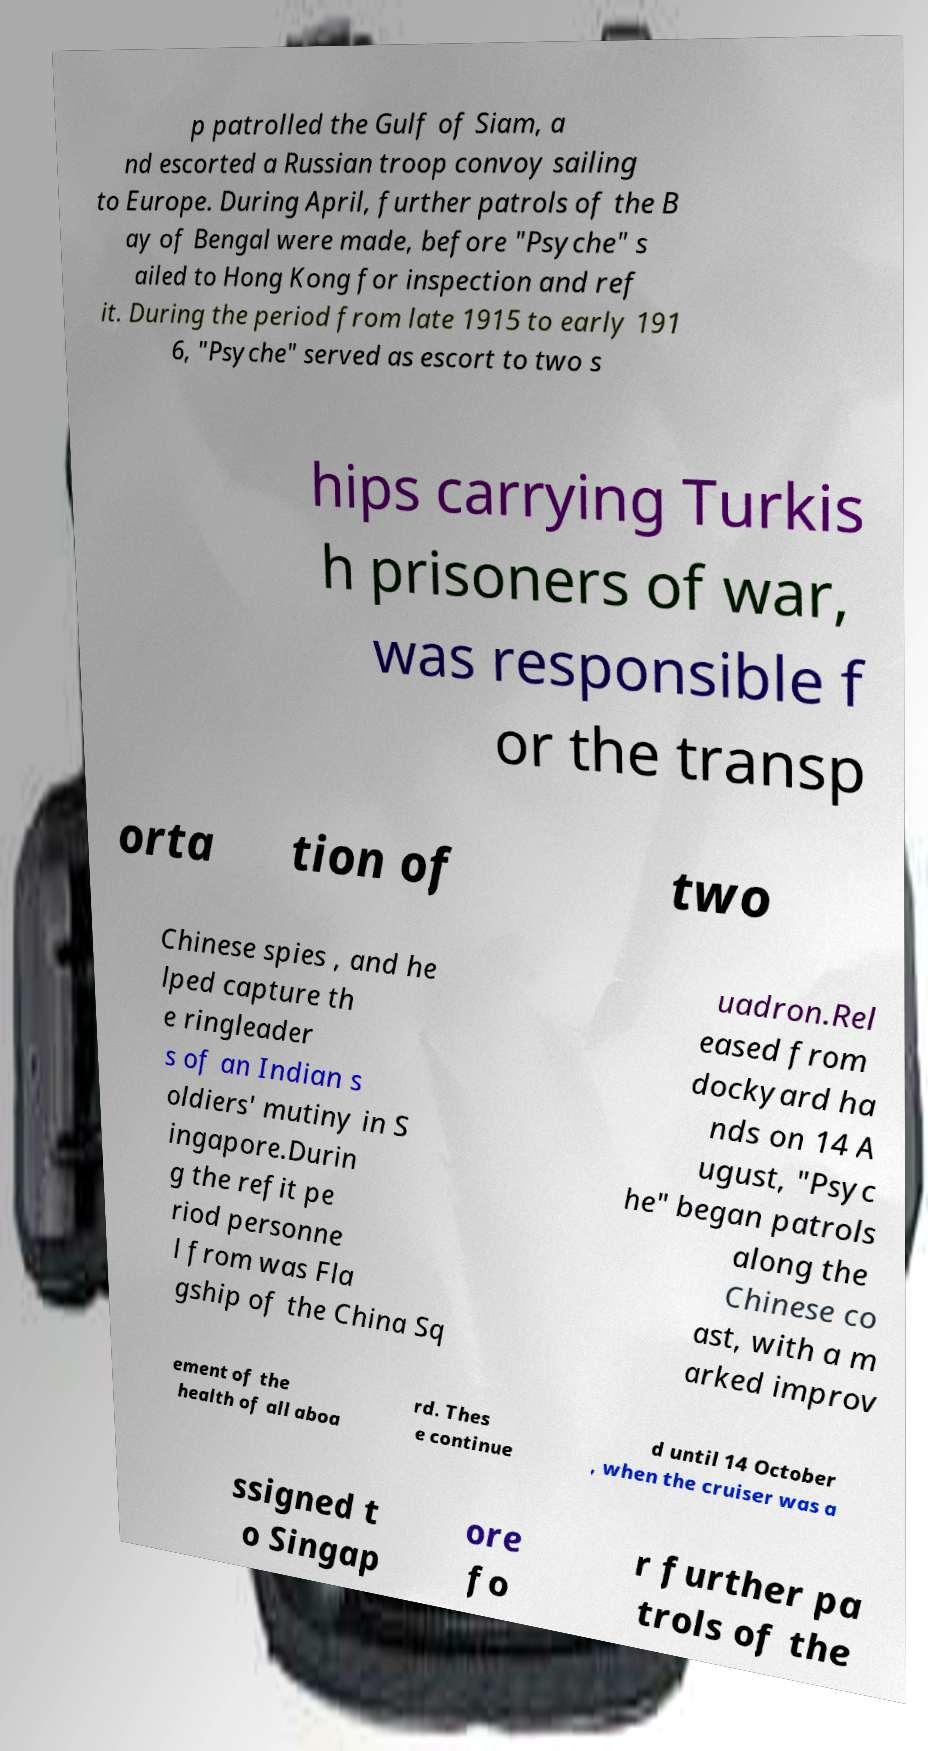Can you read and provide the text displayed in the image?This photo seems to have some interesting text. Can you extract and type it out for me? p patrolled the Gulf of Siam, a nd escorted a Russian troop convoy sailing to Europe. During April, further patrols of the B ay of Bengal were made, before "Psyche" s ailed to Hong Kong for inspection and ref it. During the period from late 1915 to early 191 6, "Psyche" served as escort to two s hips carrying Turkis h prisoners of war, was responsible f or the transp orta tion of two Chinese spies , and he lped capture th e ringleader s of an Indian s oldiers' mutiny in S ingapore.Durin g the refit pe riod personne l from was Fla gship of the China Sq uadron.Rel eased from dockyard ha nds on 14 A ugust, "Psyc he" began patrols along the Chinese co ast, with a m arked improv ement of the health of all aboa rd. Thes e continue d until 14 October , when the cruiser was a ssigned t o Singap ore fo r further pa trols of the 